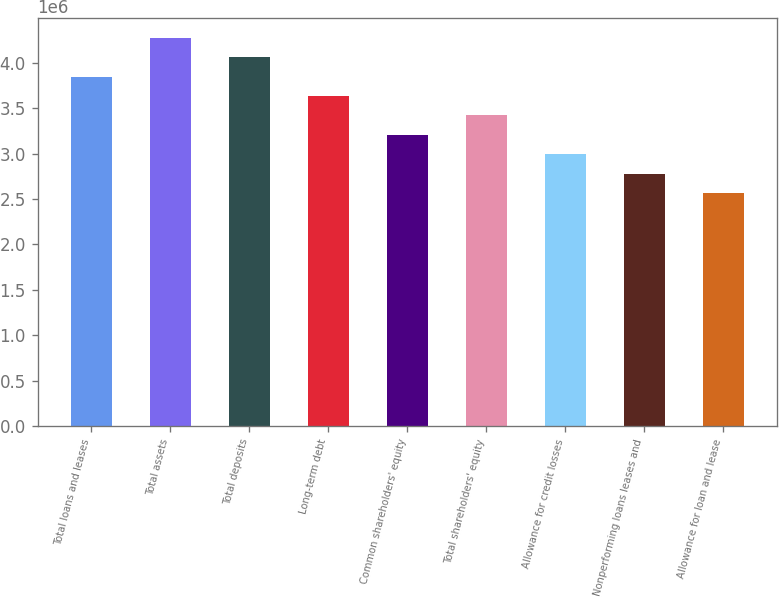Convert chart to OTSL. <chart><loc_0><loc_0><loc_500><loc_500><bar_chart><fcel>Total loans and leases<fcel>Total assets<fcel>Total deposits<fcel>Long-term debt<fcel>Common shareholders' equity<fcel>Total shareholders' equity<fcel>Allowance for credit losses<fcel>Nonperforming loans leases and<fcel>Allowance for loan and lease<nl><fcel>3.84759e+06<fcel>4.2751e+06<fcel>4.06135e+06<fcel>3.63384e+06<fcel>3.20633e+06<fcel>3.42008e+06<fcel>2.99257e+06<fcel>2.77882e+06<fcel>2.56506e+06<nl></chart> 